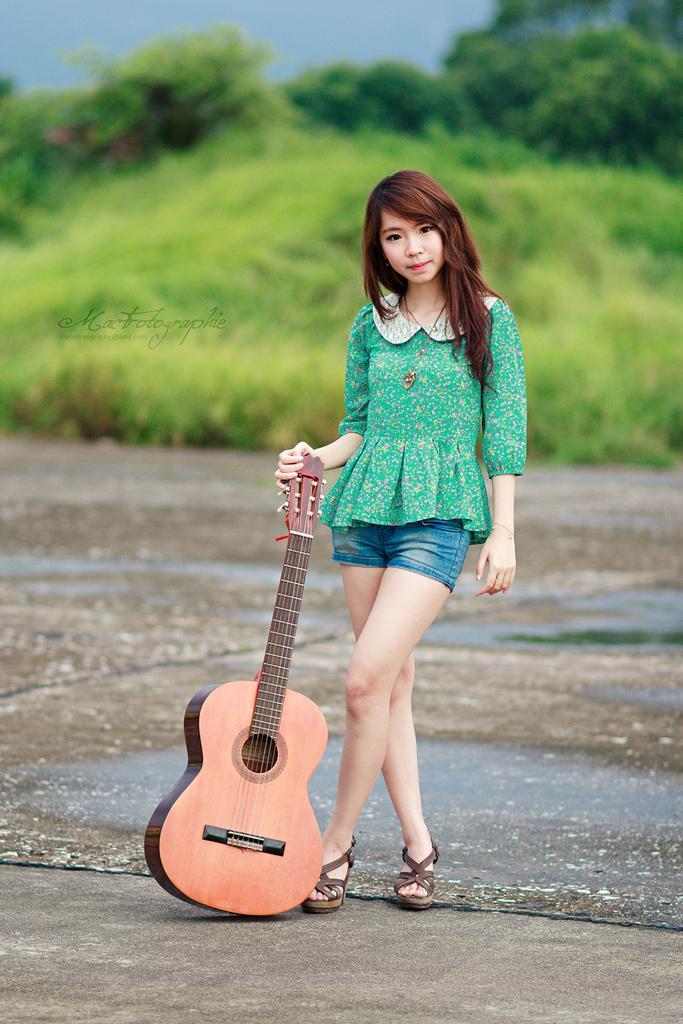Describe this image in one or two sentences. In this picture there is a girl who is standing at the center of the image, by holding the guitar there are trees behind the area of the image. 